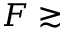Convert formula to latex. <formula><loc_0><loc_0><loc_500><loc_500>F \gtrsim</formula> 